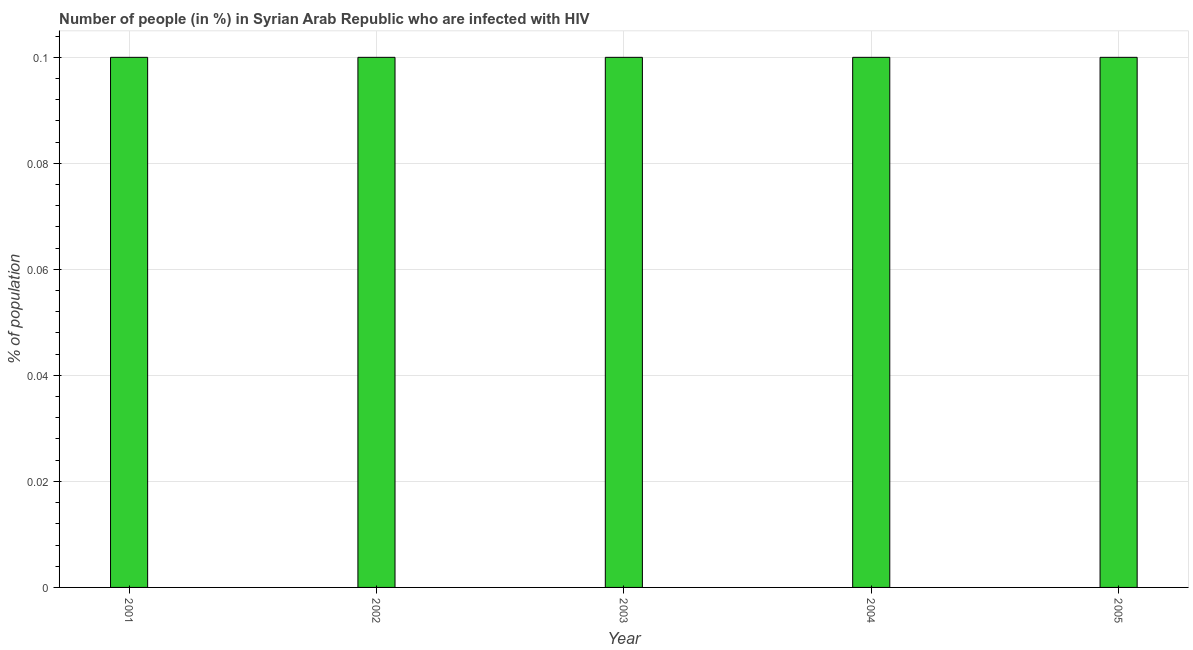What is the title of the graph?
Keep it short and to the point. Number of people (in %) in Syrian Arab Republic who are infected with HIV. What is the label or title of the Y-axis?
Your response must be concise. % of population. Across all years, what is the maximum number of people infected with hiv?
Your answer should be very brief. 0.1. In which year was the number of people infected with hiv minimum?
Make the answer very short. 2001. What is the sum of the number of people infected with hiv?
Offer a very short reply. 0.5. In how many years, is the number of people infected with hiv greater than 0.1 %?
Give a very brief answer. 0. Do a majority of the years between 2003 and 2001 (inclusive) have number of people infected with hiv greater than 0.06 %?
Ensure brevity in your answer.  Yes. Is the number of people infected with hiv in 2002 less than that in 2004?
Offer a very short reply. No. Is the sum of the number of people infected with hiv in 2004 and 2005 greater than the maximum number of people infected with hiv across all years?
Offer a very short reply. Yes. In how many years, is the number of people infected with hiv greater than the average number of people infected with hiv taken over all years?
Provide a short and direct response. 0. How many bars are there?
Your response must be concise. 5. Are the values on the major ticks of Y-axis written in scientific E-notation?
Provide a succinct answer. No. What is the % of population in 2001?
Keep it short and to the point. 0.1. What is the % of population in 2002?
Your answer should be compact. 0.1. What is the % of population in 2004?
Your response must be concise. 0.1. What is the difference between the % of population in 2001 and 2002?
Make the answer very short. 0. What is the difference between the % of population in 2001 and 2003?
Provide a short and direct response. 0. What is the difference between the % of population in 2002 and 2004?
Make the answer very short. 0. What is the difference between the % of population in 2003 and 2004?
Your answer should be compact. 0. What is the difference between the % of population in 2003 and 2005?
Keep it short and to the point. 0. What is the difference between the % of population in 2004 and 2005?
Make the answer very short. 0. What is the ratio of the % of population in 2001 to that in 2004?
Make the answer very short. 1. What is the ratio of the % of population in 2002 to that in 2003?
Make the answer very short. 1. What is the ratio of the % of population in 2003 to that in 2004?
Provide a succinct answer. 1. What is the ratio of the % of population in 2003 to that in 2005?
Your response must be concise. 1. 